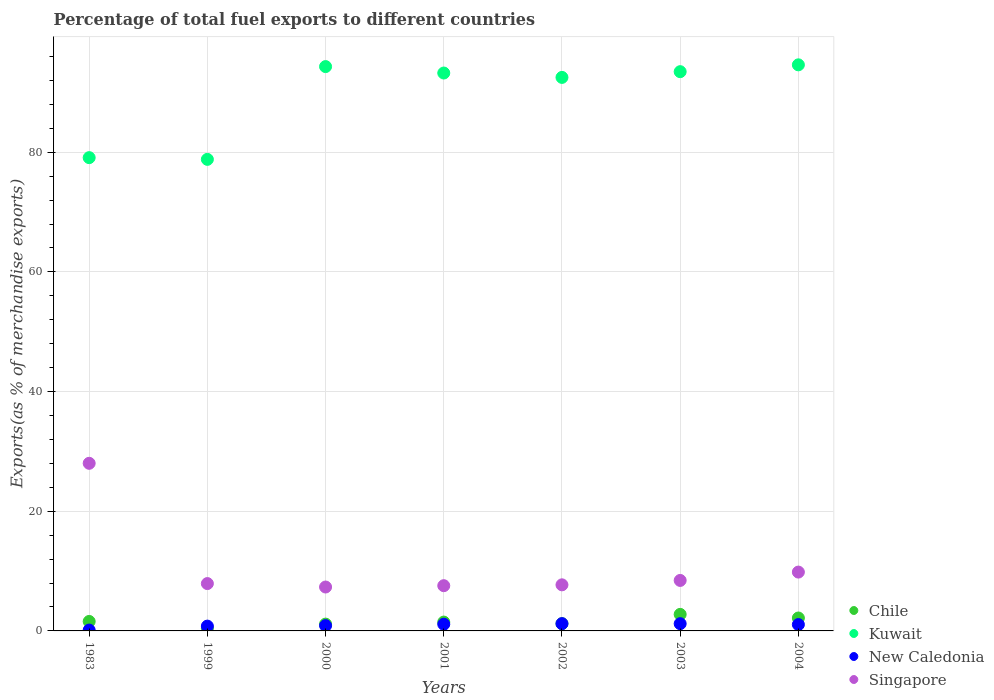How many different coloured dotlines are there?
Give a very brief answer. 4. Is the number of dotlines equal to the number of legend labels?
Offer a terse response. Yes. What is the percentage of exports to different countries in Chile in 2002?
Your answer should be very brief. 1.21. Across all years, what is the maximum percentage of exports to different countries in New Caledonia?
Keep it short and to the point. 1.22. Across all years, what is the minimum percentage of exports to different countries in Singapore?
Keep it short and to the point. 7.34. In which year was the percentage of exports to different countries in Kuwait maximum?
Keep it short and to the point. 2004. In which year was the percentage of exports to different countries in Chile minimum?
Provide a succinct answer. 1999. What is the total percentage of exports to different countries in Singapore in the graph?
Give a very brief answer. 76.79. What is the difference between the percentage of exports to different countries in New Caledonia in 1999 and that in 2000?
Keep it short and to the point. -0.08. What is the difference between the percentage of exports to different countries in New Caledonia in 1983 and the percentage of exports to different countries in Kuwait in 2001?
Give a very brief answer. -93.09. What is the average percentage of exports to different countries in Singapore per year?
Give a very brief answer. 10.97. In the year 2001, what is the difference between the percentage of exports to different countries in New Caledonia and percentage of exports to different countries in Kuwait?
Your answer should be compact. -92.11. What is the ratio of the percentage of exports to different countries in Kuwait in 2001 to that in 2003?
Your answer should be compact. 1. Is the percentage of exports to different countries in Chile in 1999 less than that in 2000?
Give a very brief answer. Yes. What is the difference between the highest and the second highest percentage of exports to different countries in New Caledonia?
Give a very brief answer. 0.01. What is the difference between the highest and the lowest percentage of exports to different countries in Chile?
Your response must be concise. 2.32. In how many years, is the percentage of exports to different countries in Chile greater than the average percentage of exports to different countries in Chile taken over all years?
Offer a terse response. 3. Is the sum of the percentage of exports to different countries in Kuwait in 2000 and 2003 greater than the maximum percentage of exports to different countries in Chile across all years?
Your answer should be very brief. Yes. Is it the case that in every year, the sum of the percentage of exports to different countries in Chile and percentage of exports to different countries in New Caledonia  is greater than the percentage of exports to different countries in Singapore?
Provide a succinct answer. No. Does the percentage of exports to different countries in Chile monotonically increase over the years?
Ensure brevity in your answer.  No. Is the percentage of exports to different countries in Chile strictly greater than the percentage of exports to different countries in Singapore over the years?
Offer a very short reply. No. How many dotlines are there?
Give a very brief answer. 4. How many years are there in the graph?
Provide a succinct answer. 7. Are the values on the major ticks of Y-axis written in scientific E-notation?
Offer a terse response. No. Does the graph contain any zero values?
Make the answer very short. No. Where does the legend appear in the graph?
Give a very brief answer. Bottom right. How many legend labels are there?
Give a very brief answer. 4. How are the legend labels stacked?
Provide a short and direct response. Vertical. What is the title of the graph?
Ensure brevity in your answer.  Percentage of total fuel exports to different countries. What is the label or title of the X-axis?
Provide a short and direct response. Years. What is the label or title of the Y-axis?
Offer a very short reply. Exports(as % of merchandise exports). What is the Exports(as % of merchandise exports) of Chile in 1983?
Offer a very short reply. 1.58. What is the Exports(as % of merchandise exports) in Kuwait in 1983?
Your answer should be compact. 79.09. What is the Exports(as % of merchandise exports) of New Caledonia in 1983?
Ensure brevity in your answer.  0.14. What is the Exports(as % of merchandise exports) of Singapore in 1983?
Your answer should be compact. 28.01. What is the Exports(as % of merchandise exports) in Chile in 1999?
Make the answer very short. 0.44. What is the Exports(as % of merchandise exports) of Kuwait in 1999?
Your answer should be compact. 78.8. What is the Exports(as % of merchandise exports) in New Caledonia in 1999?
Make the answer very short. 0.8. What is the Exports(as % of merchandise exports) of Singapore in 1999?
Make the answer very short. 7.91. What is the Exports(as % of merchandise exports) of Chile in 2000?
Your response must be concise. 1.14. What is the Exports(as % of merchandise exports) of Kuwait in 2000?
Offer a terse response. 94.31. What is the Exports(as % of merchandise exports) in New Caledonia in 2000?
Your answer should be compact. 0.88. What is the Exports(as % of merchandise exports) of Singapore in 2000?
Keep it short and to the point. 7.34. What is the Exports(as % of merchandise exports) of Chile in 2001?
Offer a very short reply. 1.48. What is the Exports(as % of merchandise exports) of Kuwait in 2001?
Your answer should be compact. 93.23. What is the Exports(as % of merchandise exports) of New Caledonia in 2001?
Provide a succinct answer. 1.12. What is the Exports(as % of merchandise exports) in Singapore in 2001?
Your answer should be compact. 7.56. What is the Exports(as % of merchandise exports) of Chile in 2002?
Make the answer very short. 1.21. What is the Exports(as % of merchandise exports) in Kuwait in 2002?
Ensure brevity in your answer.  92.5. What is the Exports(as % of merchandise exports) in New Caledonia in 2002?
Offer a very short reply. 1.22. What is the Exports(as % of merchandise exports) in Singapore in 2002?
Provide a succinct answer. 7.7. What is the Exports(as % of merchandise exports) in Chile in 2003?
Make the answer very short. 2.76. What is the Exports(as % of merchandise exports) in Kuwait in 2003?
Your answer should be compact. 93.46. What is the Exports(as % of merchandise exports) of New Caledonia in 2003?
Offer a terse response. 1.21. What is the Exports(as % of merchandise exports) in Singapore in 2003?
Make the answer very short. 8.44. What is the Exports(as % of merchandise exports) of Chile in 2004?
Your answer should be compact. 2.16. What is the Exports(as % of merchandise exports) in Kuwait in 2004?
Your answer should be compact. 94.6. What is the Exports(as % of merchandise exports) of New Caledonia in 2004?
Offer a terse response. 1.06. What is the Exports(as % of merchandise exports) in Singapore in 2004?
Offer a very short reply. 9.83. Across all years, what is the maximum Exports(as % of merchandise exports) in Chile?
Keep it short and to the point. 2.76. Across all years, what is the maximum Exports(as % of merchandise exports) of Kuwait?
Ensure brevity in your answer.  94.6. Across all years, what is the maximum Exports(as % of merchandise exports) in New Caledonia?
Your answer should be very brief. 1.22. Across all years, what is the maximum Exports(as % of merchandise exports) in Singapore?
Give a very brief answer. 28.01. Across all years, what is the minimum Exports(as % of merchandise exports) of Chile?
Your answer should be very brief. 0.44. Across all years, what is the minimum Exports(as % of merchandise exports) in Kuwait?
Your answer should be compact. 78.8. Across all years, what is the minimum Exports(as % of merchandise exports) of New Caledonia?
Your answer should be compact. 0.14. Across all years, what is the minimum Exports(as % of merchandise exports) of Singapore?
Offer a terse response. 7.34. What is the total Exports(as % of merchandise exports) of Chile in the graph?
Give a very brief answer. 10.77. What is the total Exports(as % of merchandise exports) in Kuwait in the graph?
Give a very brief answer. 625.98. What is the total Exports(as % of merchandise exports) of New Caledonia in the graph?
Keep it short and to the point. 6.43. What is the total Exports(as % of merchandise exports) of Singapore in the graph?
Ensure brevity in your answer.  76.79. What is the difference between the Exports(as % of merchandise exports) in Chile in 1983 and that in 1999?
Your answer should be very brief. 1.14. What is the difference between the Exports(as % of merchandise exports) in Kuwait in 1983 and that in 1999?
Offer a very short reply. 0.29. What is the difference between the Exports(as % of merchandise exports) of New Caledonia in 1983 and that in 1999?
Make the answer very short. -0.66. What is the difference between the Exports(as % of merchandise exports) in Singapore in 1983 and that in 1999?
Your answer should be compact. 20.1. What is the difference between the Exports(as % of merchandise exports) in Chile in 1983 and that in 2000?
Make the answer very short. 0.45. What is the difference between the Exports(as % of merchandise exports) in Kuwait in 1983 and that in 2000?
Keep it short and to the point. -15.22. What is the difference between the Exports(as % of merchandise exports) in New Caledonia in 1983 and that in 2000?
Your answer should be compact. -0.74. What is the difference between the Exports(as % of merchandise exports) of Singapore in 1983 and that in 2000?
Your response must be concise. 20.67. What is the difference between the Exports(as % of merchandise exports) in Chile in 1983 and that in 2001?
Your answer should be very brief. 0.11. What is the difference between the Exports(as % of merchandise exports) of Kuwait in 1983 and that in 2001?
Give a very brief answer. -14.14. What is the difference between the Exports(as % of merchandise exports) of New Caledonia in 1983 and that in 2001?
Provide a short and direct response. -0.98. What is the difference between the Exports(as % of merchandise exports) in Singapore in 1983 and that in 2001?
Offer a very short reply. 20.45. What is the difference between the Exports(as % of merchandise exports) in Chile in 1983 and that in 2002?
Provide a succinct answer. 0.37. What is the difference between the Exports(as % of merchandise exports) of Kuwait in 1983 and that in 2002?
Give a very brief answer. -13.41. What is the difference between the Exports(as % of merchandise exports) of New Caledonia in 1983 and that in 2002?
Provide a short and direct response. -1.07. What is the difference between the Exports(as % of merchandise exports) in Singapore in 1983 and that in 2002?
Your answer should be compact. 20.31. What is the difference between the Exports(as % of merchandise exports) of Chile in 1983 and that in 2003?
Your answer should be very brief. -1.18. What is the difference between the Exports(as % of merchandise exports) in Kuwait in 1983 and that in 2003?
Provide a succinct answer. -14.37. What is the difference between the Exports(as % of merchandise exports) of New Caledonia in 1983 and that in 2003?
Provide a succinct answer. -1.07. What is the difference between the Exports(as % of merchandise exports) of Singapore in 1983 and that in 2003?
Offer a very short reply. 19.57. What is the difference between the Exports(as % of merchandise exports) of Chile in 1983 and that in 2004?
Your answer should be very brief. -0.58. What is the difference between the Exports(as % of merchandise exports) of Kuwait in 1983 and that in 2004?
Make the answer very short. -15.51. What is the difference between the Exports(as % of merchandise exports) of New Caledonia in 1983 and that in 2004?
Give a very brief answer. -0.92. What is the difference between the Exports(as % of merchandise exports) of Singapore in 1983 and that in 2004?
Give a very brief answer. 18.18. What is the difference between the Exports(as % of merchandise exports) of Chile in 1999 and that in 2000?
Give a very brief answer. -0.69. What is the difference between the Exports(as % of merchandise exports) in Kuwait in 1999 and that in 2000?
Provide a short and direct response. -15.5. What is the difference between the Exports(as % of merchandise exports) in New Caledonia in 1999 and that in 2000?
Offer a very short reply. -0.08. What is the difference between the Exports(as % of merchandise exports) of Singapore in 1999 and that in 2000?
Offer a terse response. 0.57. What is the difference between the Exports(as % of merchandise exports) in Chile in 1999 and that in 2001?
Your answer should be compact. -1.03. What is the difference between the Exports(as % of merchandise exports) of Kuwait in 1999 and that in 2001?
Give a very brief answer. -14.43. What is the difference between the Exports(as % of merchandise exports) of New Caledonia in 1999 and that in 2001?
Provide a succinct answer. -0.32. What is the difference between the Exports(as % of merchandise exports) in Singapore in 1999 and that in 2001?
Provide a short and direct response. 0.35. What is the difference between the Exports(as % of merchandise exports) of Chile in 1999 and that in 2002?
Your answer should be very brief. -0.77. What is the difference between the Exports(as % of merchandise exports) of Kuwait in 1999 and that in 2002?
Your answer should be compact. -13.7. What is the difference between the Exports(as % of merchandise exports) of New Caledonia in 1999 and that in 2002?
Offer a very short reply. -0.41. What is the difference between the Exports(as % of merchandise exports) in Singapore in 1999 and that in 2002?
Provide a short and direct response. 0.21. What is the difference between the Exports(as % of merchandise exports) of Chile in 1999 and that in 2003?
Give a very brief answer. -2.32. What is the difference between the Exports(as % of merchandise exports) of Kuwait in 1999 and that in 2003?
Your answer should be very brief. -14.65. What is the difference between the Exports(as % of merchandise exports) in New Caledonia in 1999 and that in 2003?
Provide a short and direct response. -0.41. What is the difference between the Exports(as % of merchandise exports) in Singapore in 1999 and that in 2003?
Offer a terse response. -0.53. What is the difference between the Exports(as % of merchandise exports) of Chile in 1999 and that in 2004?
Your answer should be very brief. -1.72. What is the difference between the Exports(as % of merchandise exports) of Kuwait in 1999 and that in 2004?
Offer a very short reply. -15.8. What is the difference between the Exports(as % of merchandise exports) in New Caledonia in 1999 and that in 2004?
Ensure brevity in your answer.  -0.26. What is the difference between the Exports(as % of merchandise exports) of Singapore in 1999 and that in 2004?
Offer a very short reply. -1.92. What is the difference between the Exports(as % of merchandise exports) in Chile in 2000 and that in 2001?
Provide a short and direct response. -0.34. What is the difference between the Exports(as % of merchandise exports) of Kuwait in 2000 and that in 2001?
Ensure brevity in your answer.  1.08. What is the difference between the Exports(as % of merchandise exports) in New Caledonia in 2000 and that in 2001?
Make the answer very short. -0.24. What is the difference between the Exports(as % of merchandise exports) of Singapore in 2000 and that in 2001?
Your answer should be compact. -0.22. What is the difference between the Exports(as % of merchandise exports) in Chile in 2000 and that in 2002?
Make the answer very short. -0.07. What is the difference between the Exports(as % of merchandise exports) of Kuwait in 2000 and that in 2002?
Your response must be concise. 1.81. What is the difference between the Exports(as % of merchandise exports) of New Caledonia in 2000 and that in 2002?
Offer a very short reply. -0.33. What is the difference between the Exports(as % of merchandise exports) of Singapore in 2000 and that in 2002?
Provide a short and direct response. -0.37. What is the difference between the Exports(as % of merchandise exports) in Chile in 2000 and that in 2003?
Your answer should be very brief. -1.63. What is the difference between the Exports(as % of merchandise exports) in Kuwait in 2000 and that in 2003?
Keep it short and to the point. 0.85. What is the difference between the Exports(as % of merchandise exports) in New Caledonia in 2000 and that in 2003?
Make the answer very short. -0.33. What is the difference between the Exports(as % of merchandise exports) of Singapore in 2000 and that in 2003?
Provide a short and direct response. -1.1. What is the difference between the Exports(as % of merchandise exports) of Chile in 2000 and that in 2004?
Provide a short and direct response. -1.02. What is the difference between the Exports(as % of merchandise exports) in Kuwait in 2000 and that in 2004?
Make the answer very short. -0.29. What is the difference between the Exports(as % of merchandise exports) in New Caledonia in 2000 and that in 2004?
Give a very brief answer. -0.18. What is the difference between the Exports(as % of merchandise exports) in Singapore in 2000 and that in 2004?
Your answer should be compact. -2.5. What is the difference between the Exports(as % of merchandise exports) of Chile in 2001 and that in 2002?
Your answer should be compact. 0.27. What is the difference between the Exports(as % of merchandise exports) in Kuwait in 2001 and that in 2002?
Provide a short and direct response. 0.73. What is the difference between the Exports(as % of merchandise exports) in New Caledonia in 2001 and that in 2002?
Offer a terse response. -0.1. What is the difference between the Exports(as % of merchandise exports) of Singapore in 2001 and that in 2002?
Your response must be concise. -0.14. What is the difference between the Exports(as % of merchandise exports) in Chile in 2001 and that in 2003?
Provide a short and direct response. -1.29. What is the difference between the Exports(as % of merchandise exports) of Kuwait in 2001 and that in 2003?
Offer a very short reply. -0.23. What is the difference between the Exports(as % of merchandise exports) of New Caledonia in 2001 and that in 2003?
Provide a short and direct response. -0.09. What is the difference between the Exports(as % of merchandise exports) in Singapore in 2001 and that in 2003?
Give a very brief answer. -0.88. What is the difference between the Exports(as % of merchandise exports) of Chile in 2001 and that in 2004?
Offer a very short reply. -0.68. What is the difference between the Exports(as % of merchandise exports) in Kuwait in 2001 and that in 2004?
Give a very brief answer. -1.37. What is the difference between the Exports(as % of merchandise exports) in New Caledonia in 2001 and that in 2004?
Ensure brevity in your answer.  0.06. What is the difference between the Exports(as % of merchandise exports) in Singapore in 2001 and that in 2004?
Your answer should be compact. -2.27. What is the difference between the Exports(as % of merchandise exports) in Chile in 2002 and that in 2003?
Ensure brevity in your answer.  -1.55. What is the difference between the Exports(as % of merchandise exports) in Kuwait in 2002 and that in 2003?
Your response must be concise. -0.96. What is the difference between the Exports(as % of merchandise exports) in New Caledonia in 2002 and that in 2003?
Your answer should be very brief. 0.01. What is the difference between the Exports(as % of merchandise exports) of Singapore in 2002 and that in 2003?
Give a very brief answer. -0.73. What is the difference between the Exports(as % of merchandise exports) of Chile in 2002 and that in 2004?
Provide a succinct answer. -0.95. What is the difference between the Exports(as % of merchandise exports) in New Caledonia in 2002 and that in 2004?
Make the answer very short. 0.15. What is the difference between the Exports(as % of merchandise exports) of Singapore in 2002 and that in 2004?
Your answer should be compact. -2.13. What is the difference between the Exports(as % of merchandise exports) of Chile in 2003 and that in 2004?
Make the answer very short. 0.6. What is the difference between the Exports(as % of merchandise exports) in Kuwait in 2003 and that in 2004?
Offer a very short reply. -1.14. What is the difference between the Exports(as % of merchandise exports) in New Caledonia in 2003 and that in 2004?
Provide a succinct answer. 0.15. What is the difference between the Exports(as % of merchandise exports) in Singapore in 2003 and that in 2004?
Make the answer very short. -1.4. What is the difference between the Exports(as % of merchandise exports) in Chile in 1983 and the Exports(as % of merchandise exports) in Kuwait in 1999?
Your answer should be compact. -77.22. What is the difference between the Exports(as % of merchandise exports) of Chile in 1983 and the Exports(as % of merchandise exports) of New Caledonia in 1999?
Give a very brief answer. 0.78. What is the difference between the Exports(as % of merchandise exports) in Chile in 1983 and the Exports(as % of merchandise exports) in Singapore in 1999?
Make the answer very short. -6.33. What is the difference between the Exports(as % of merchandise exports) in Kuwait in 1983 and the Exports(as % of merchandise exports) in New Caledonia in 1999?
Offer a terse response. 78.29. What is the difference between the Exports(as % of merchandise exports) of Kuwait in 1983 and the Exports(as % of merchandise exports) of Singapore in 1999?
Your response must be concise. 71.18. What is the difference between the Exports(as % of merchandise exports) in New Caledonia in 1983 and the Exports(as % of merchandise exports) in Singapore in 1999?
Your answer should be very brief. -7.77. What is the difference between the Exports(as % of merchandise exports) of Chile in 1983 and the Exports(as % of merchandise exports) of Kuwait in 2000?
Offer a very short reply. -92.72. What is the difference between the Exports(as % of merchandise exports) in Chile in 1983 and the Exports(as % of merchandise exports) in New Caledonia in 2000?
Keep it short and to the point. 0.7. What is the difference between the Exports(as % of merchandise exports) of Chile in 1983 and the Exports(as % of merchandise exports) of Singapore in 2000?
Keep it short and to the point. -5.75. What is the difference between the Exports(as % of merchandise exports) of Kuwait in 1983 and the Exports(as % of merchandise exports) of New Caledonia in 2000?
Your answer should be very brief. 78.21. What is the difference between the Exports(as % of merchandise exports) in Kuwait in 1983 and the Exports(as % of merchandise exports) in Singapore in 2000?
Give a very brief answer. 71.75. What is the difference between the Exports(as % of merchandise exports) in New Caledonia in 1983 and the Exports(as % of merchandise exports) in Singapore in 2000?
Offer a very short reply. -7.2. What is the difference between the Exports(as % of merchandise exports) in Chile in 1983 and the Exports(as % of merchandise exports) in Kuwait in 2001?
Offer a very short reply. -91.65. What is the difference between the Exports(as % of merchandise exports) in Chile in 1983 and the Exports(as % of merchandise exports) in New Caledonia in 2001?
Offer a very short reply. 0.46. What is the difference between the Exports(as % of merchandise exports) of Chile in 1983 and the Exports(as % of merchandise exports) of Singapore in 2001?
Make the answer very short. -5.98. What is the difference between the Exports(as % of merchandise exports) in Kuwait in 1983 and the Exports(as % of merchandise exports) in New Caledonia in 2001?
Provide a succinct answer. 77.97. What is the difference between the Exports(as % of merchandise exports) of Kuwait in 1983 and the Exports(as % of merchandise exports) of Singapore in 2001?
Make the answer very short. 71.53. What is the difference between the Exports(as % of merchandise exports) in New Caledonia in 1983 and the Exports(as % of merchandise exports) in Singapore in 2001?
Your answer should be compact. -7.42. What is the difference between the Exports(as % of merchandise exports) in Chile in 1983 and the Exports(as % of merchandise exports) in Kuwait in 2002?
Provide a short and direct response. -90.92. What is the difference between the Exports(as % of merchandise exports) in Chile in 1983 and the Exports(as % of merchandise exports) in New Caledonia in 2002?
Your answer should be compact. 0.37. What is the difference between the Exports(as % of merchandise exports) in Chile in 1983 and the Exports(as % of merchandise exports) in Singapore in 2002?
Provide a succinct answer. -6.12. What is the difference between the Exports(as % of merchandise exports) in Kuwait in 1983 and the Exports(as % of merchandise exports) in New Caledonia in 2002?
Your answer should be very brief. 77.87. What is the difference between the Exports(as % of merchandise exports) in Kuwait in 1983 and the Exports(as % of merchandise exports) in Singapore in 2002?
Make the answer very short. 71.39. What is the difference between the Exports(as % of merchandise exports) of New Caledonia in 1983 and the Exports(as % of merchandise exports) of Singapore in 2002?
Offer a terse response. -7.56. What is the difference between the Exports(as % of merchandise exports) of Chile in 1983 and the Exports(as % of merchandise exports) of Kuwait in 2003?
Your response must be concise. -91.87. What is the difference between the Exports(as % of merchandise exports) of Chile in 1983 and the Exports(as % of merchandise exports) of New Caledonia in 2003?
Your answer should be compact. 0.37. What is the difference between the Exports(as % of merchandise exports) of Chile in 1983 and the Exports(as % of merchandise exports) of Singapore in 2003?
Your answer should be very brief. -6.85. What is the difference between the Exports(as % of merchandise exports) of Kuwait in 1983 and the Exports(as % of merchandise exports) of New Caledonia in 2003?
Give a very brief answer. 77.88. What is the difference between the Exports(as % of merchandise exports) in Kuwait in 1983 and the Exports(as % of merchandise exports) in Singapore in 2003?
Give a very brief answer. 70.65. What is the difference between the Exports(as % of merchandise exports) in New Caledonia in 1983 and the Exports(as % of merchandise exports) in Singapore in 2003?
Provide a succinct answer. -8.3. What is the difference between the Exports(as % of merchandise exports) in Chile in 1983 and the Exports(as % of merchandise exports) in Kuwait in 2004?
Make the answer very short. -93.02. What is the difference between the Exports(as % of merchandise exports) of Chile in 1983 and the Exports(as % of merchandise exports) of New Caledonia in 2004?
Offer a terse response. 0.52. What is the difference between the Exports(as % of merchandise exports) of Chile in 1983 and the Exports(as % of merchandise exports) of Singapore in 2004?
Your response must be concise. -8.25. What is the difference between the Exports(as % of merchandise exports) of Kuwait in 1983 and the Exports(as % of merchandise exports) of New Caledonia in 2004?
Your response must be concise. 78.03. What is the difference between the Exports(as % of merchandise exports) in Kuwait in 1983 and the Exports(as % of merchandise exports) in Singapore in 2004?
Keep it short and to the point. 69.26. What is the difference between the Exports(as % of merchandise exports) in New Caledonia in 1983 and the Exports(as % of merchandise exports) in Singapore in 2004?
Give a very brief answer. -9.69. What is the difference between the Exports(as % of merchandise exports) in Chile in 1999 and the Exports(as % of merchandise exports) in Kuwait in 2000?
Provide a succinct answer. -93.86. What is the difference between the Exports(as % of merchandise exports) of Chile in 1999 and the Exports(as % of merchandise exports) of New Caledonia in 2000?
Offer a terse response. -0.44. What is the difference between the Exports(as % of merchandise exports) in Chile in 1999 and the Exports(as % of merchandise exports) in Singapore in 2000?
Your answer should be compact. -6.89. What is the difference between the Exports(as % of merchandise exports) in Kuwait in 1999 and the Exports(as % of merchandise exports) in New Caledonia in 2000?
Offer a very short reply. 77.92. What is the difference between the Exports(as % of merchandise exports) in Kuwait in 1999 and the Exports(as % of merchandise exports) in Singapore in 2000?
Make the answer very short. 71.47. What is the difference between the Exports(as % of merchandise exports) in New Caledonia in 1999 and the Exports(as % of merchandise exports) in Singapore in 2000?
Provide a succinct answer. -6.53. What is the difference between the Exports(as % of merchandise exports) of Chile in 1999 and the Exports(as % of merchandise exports) of Kuwait in 2001?
Provide a short and direct response. -92.79. What is the difference between the Exports(as % of merchandise exports) of Chile in 1999 and the Exports(as % of merchandise exports) of New Caledonia in 2001?
Keep it short and to the point. -0.68. What is the difference between the Exports(as % of merchandise exports) in Chile in 1999 and the Exports(as % of merchandise exports) in Singapore in 2001?
Give a very brief answer. -7.12. What is the difference between the Exports(as % of merchandise exports) in Kuwait in 1999 and the Exports(as % of merchandise exports) in New Caledonia in 2001?
Provide a succinct answer. 77.68. What is the difference between the Exports(as % of merchandise exports) in Kuwait in 1999 and the Exports(as % of merchandise exports) in Singapore in 2001?
Make the answer very short. 71.24. What is the difference between the Exports(as % of merchandise exports) in New Caledonia in 1999 and the Exports(as % of merchandise exports) in Singapore in 2001?
Your response must be concise. -6.76. What is the difference between the Exports(as % of merchandise exports) of Chile in 1999 and the Exports(as % of merchandise exports) of Kuwait in 2002?
Your answer should be very brief. -92.06. What is the difference between the Exports(as % of merchandise exports) in Chile in 1999 and the Exports(as % of merchandise exports) in New Caledonia in 2002?
Keep it short and to the point. -0.77. What is the difference between the Exports(as % of merchandise exports) in Chile in 1999 and the Exports(as % of merchandise exports) in Singapore in 2002?
Provide a succinct answer. -7.26. What is the difference between the Exports(as % of merchandise exports) of Kuwait in 1999 and the Exports(as % of merchandise exports) of New Caledonia in 2002?
Keep it short and to the point. 77.59. What is the difference between the Exports(as % of merchandise exports) of Kuwait in 1999 and the Exports(as % of merchandise exports) of Singapore in 2002?
Your answer should be very brief. 71.1. What is the difference between the Exports(as % of merchandise exports) in New Caledonia in 1999 and the Exports(as % of merchandise exports) in Singapore in 2002?
Your answer should be very brief. -6.9. What is the difference between the Exports(as % of merchandise exports) of Chile in 1999 and the Exports(as % of merchandise exports) of Kuwait in 2003?
Keep it short and to the point. -93.01. What is the difference between the Exports(as % of merchandise exports) in Chile in 1999 and the Exports(as % of merchandise exports) in New Caledonia in 2003?
Provide a succinct answer. -0.77. What is the difference between the Exports(as % of merchandise exports) in Chile in 1999 and the Exports(as % of merchandise exports) in Singapore in 2003?
Give a very brief answer. -7.99. What is the difference between the Exports(as % of merchandise exports) of Kuwait in 1999 and the Exports(as % of merchandise exports) of New Caledonia in 2003?
Your answer should be compact. 77.59. What is the difference between the Exports(as % of merchandise exports) of Kuwait in 1999 and the Exports(as % of merchandise exports) of Singapore in 2003?
Offer a very short reply. 70.37. What is the difference between the Exports(as % of merchandise exports) in New Caledonia in 1999 and the Exports(as % of merchandise exports) in Singapore in 2003?
Your answer should be compact. -7.63. What is the difference between the Exports(as % of merchandise exports) in Chile in 1999 and the Exports(as % of merchandise exports) in Kuwait in 2004?
Your response must be concise. -94.16. What is the difference between the Exports(as % of merchandise exports) of Chile in 1999 and the Exports(as % of merchandise exports) of New Caledonia in 2004?
Offer a terse response. -0.62. What is the difference between the Exports(as % of merchandise exports) of Chile in 1999 and the Exports(as % of merchandise exports) of Singapore in 2004?
Make the answer very short. -9.39. What is the difference between the Exports(as % of merchandise exports) of Kuwait in 1999 and the Exports(as % of merchandise exports) of New Caledonia in 2004?
Provide a succinct answer. 77.74. What is the difference between the Exports(as % of merchandise exports) of Kuwait in 1999 and the Exports(as % of merchandise exports) of Singapore in 2004?
Offer a very short reply. 68.97. What is the difference between the Exports(as % of merchandise exports) in New Caledonia in 1999 and the Exports(as % of merchandise exports) in Singapore in 2004?
Give a very brief answer. -9.03. What is the difference between the Exports(as % of merchandise exports) of Chile in 2000 and the Exports(as % of merchandise exports) of Kuwait in 2001?
Your response must be concise. -92.09. What is the difference between the Exports(as % of merchandise exports) of Chile in 2000 and the Exports(as % of merchandise exports) of New Caledonia in 2001?
Provide a succinct answer. 0.02. What is the difference between the Exports(as % of merchandise exports) of Chile in 2000 and the Exports(as % of merchandise exports) of Singapore in 2001?
Make the answer very short. -6.42. What is the difference between the Exports(as % of merchandise exports) of Kuwait in 2000 and the Exports(as % of merchandise exports) of New Caledonia in 2001?
Your response must be concise. 93.19. What is the difference between the Exports(as % of merchandise exports) of Kuwait in 2000 and the Exports(as % of merchandise exports) of Singapore in 2001?
Offer a very short reply. 86.75. What is the difference between the Exports(as % of merchandise exports) in New Caledonia in 2000 and the Exports(as % of merchandise exports) in Singapore in 2001?
Make the answer very short. -6.68. What is the difference between the Exports(as % of merchandise exports) in Chile in 2000 and the Exports(as % of merchandise exports) in Kuwait in 2002?
Give a very brief answer. -91.36. What is the difference between the Exports(as % of merchandise exports) in Chile in 2000 and the Exports(as % of merchandise exports) in New Caledonia in 2002?
Make the answer very short. -0.08. What is the difference between the Exports(as % of merchandise exports) of Chile in 2000 and the Exports(as % of merchandise exports) of Singapore in 2002?
Ensure brevity in your answer.  -6.56. What is the difference between the Exports(as % of merchandise exports) in Kuwait in 2000 and the Exports(as % of merchandise exports) in New Caledonia in 2002?
Offer a terse response. 93.09. What is the difference between the Exports(as % of merchandise exports) of Kuwait in 2000 and the Exports(as % of merchandise exports) of Singapore in 2002?
Provide a succinct answer. 86.6. What is the difference between the Exports(as % of merchandise exports) in New Caledonia in 2000 and the Exports(as % of merchandise exports) in Singapore in 2002?
Your answer should be very brief. -6.82. What is the difference between the Exports(as % of merchandise exports) of Chile in 2000 and the Exports(as % of merchandise exports) of Kuwait in 2003?
Ensure brevity in your answer.  -92.32. What is the difference between the Exports(as % of merchandise exports) in Chile in 2000 and the Exports(as % of merchandise exports) in New Caledonia in 2003?
Keep it short and to the point. -0.07. What is the difference between the Exports(as % of merchandise exports) in Chile in 2000 and the Exports(as % of merchandise exports) in Singapore in 2003?
Give a very brief answer. -7.3. What is the difference between the Exports(as % of merchandise exports) in Kuwait in 2000 and the Exports(as % of merchandise exports) in New Caledonia in 2003?
Offer a terse response. 93.1. What is the difference between the Exports(as % of merchandise exports) in Kuwait in 2000 and the Exports(as % of merchandise exports) in Singapore in 2003?
Provide a short and direct response. 85.87. What is the difference between the Exports(as % of merchandise exports) in New Caledonia in 2000 and the Exports(as % of merchandise exports) in Singapore in 2003?
Offer a very short reply. -7.55. What is the difference between the Exports(as % of merchandise exports) in Chile in 2000 and the Exports(as % of merchandise exports) in Kuwait in 2004?
Your answer should be very brief. -93.46. What is the difference between the Exports(as % of merchandise exports) in Chile in 2000 and the Exports(as % of merchandise exports) in New Caledonia in 2004?
Offer a very short reply. 0.07. What is the difference between the Exports(as % of merchandise exports) in Chile in 2000 and the Exports(as % of merchandise exports) in Singapore in 2004?
Your answer should be compact. -8.69. What is the difference between the Exports(as % of merchandise exports) of Kuwait in 2000 and the Exports(as % of merchandise exports) of New Caledonia in 2004?
Make the answer very short. 93.24. What is the difference between the Exports(as % of merchandise exports) of Kuwait in 2000 and the Exports(as % of merchandise exports) of Singapore in 2004?
Provide a short and direct response. 84.47. What is the difference between the Exports(as % of merchandise exports) in New Caledonia in 2000 and the Exports(as % of merchandise exports) in Singapore in 2004?
Provide a short and direct response. -8.95. What is the difference between the Exports(as % of merchandise exports) in Chile in 2001 and the Exports(as % of merchandise exports) in Kuwait in 2002?
Provide a succinct answer. -91.02. What is the difference between the Exports(as % of merchandise exports) in Chile in 2001 and the Exports(as % of merchandise exports) in New Caledonia in 2002?
Make the answer very short. 0.26. What is the difference between the Exports(as % of merchandise exports) in Chile in 2001 and the Exports(as % of merchandise exports) in Singapore in 2002?
Your answer should be very brief. -6.23. What is the difference between the Exports(as % of merchandise exports) of Kuwait in 2001 and the Exports(as % of merchandise exports) of New Caledonia in 2002?
Your answer should be very brief. 92.02. What is the difference between the Exports(as % of merchandise exports) in Kuwait in 2001 and the Exports(as % of merchandise exports) in Singapore in 2002?
Provide a succinct answer. 85.53. What is the difference between the Exports(as % of merchandise exports) of New Caledonia in 2001 and the Exports(as % of merchandise exports) of Singapore in 2002?
Provide a short and direct response. -6.58. What is the difference between the Exports(as % of merchandise exports) of Chile in 2001 and the Exports(as % of merchandise exports) of Kuwait in 2003?
Ensure brevity in your answer.  -91.98. What is the difference between the Exports(as % of merchandise exports) of Chile in 2001 and the Exports(as % of merchandise exports) of New Caledonia in 2003?
Give a very brief answer. 0.27. What is the difference between the Exports(as % of merchandise exports) of Chile in 2001 and the Exports(as % of merchandise exports) of Singapore in 2003?
Make the answer very short. -6.96. What is the difference between the Exports(as % of merchandise exports) of Kuwait in 2001 and the Exports(as % of merchandise exports) of New Caledonia in 2003?
Give a very brief answer. 92.02. What is the difference between the Exports(as % of merchandise exports) in Kuwait in 2001 and the Exports(as % of merchandise exports) in Singapore in 2003?
Offer a very short reply. 84.79. What is the difference between the Exports(as % of merchandise exports) in New Caledonia in 2001 and the Exports(as % of merchandise exports) in Singapore in 2003?
Offer a very short reply. -7.32. What is the difference between the Exports(as % of merchandise exports) of Chile in 2001 and the Exports(as % of merchandise exports) of Kuwait in 2004?
Offer a very short reply. -93.12. What is the difference between the Exports(as % of merchandise exports) in Chile in 2001 and the Exports(as % of merchandise exports) in New Caledonia in 2004?
Your answer should be very brief. 0.41. What is the difference between the Exports(as % of merchandise exports) of Chile in 2001 and the Exports(as % of merchandise exports) of Singapore in 2004?
Provide a succinct answer. -8.36. What is the difference between the Exports(as % of merchandise exports) in Kuwait in 2001 and the Exports(as % of merchandise exports) in New Caledonia in 2004?
Offer a terse response. 92.17. What is the difference between the Exports(as % of merchandise exports) of Kuwait in 2001 and the Exports(as % of merchandise exports) of Singapore in 2004?
Provide a short and direct response. 83.4. What is the difference between the Exports(as % of merchandise exports) of New Caledonia in 2001 and the Exports(as % of merchandise exports) of Singapore in 2004?
Your response must be concise. -8.71. What is the difference between the Exports(as % of merchandise exports) in Chile in 2002 and the Exports(as % of merchandise exports) in Kuwait in 2003?
Keep it short and to the point. -92.25. What is the difference between the Exports(as % of merchandise exports) in Chile in 2002 and the Exports(as % of merchandise exports) in Singapore in 2003?
Provide a succinct answer. -7.23. What is the difference between the Exports(as % of merchandise exports) of Kuwait in 2002 and the Exports(as % of merchandise exports) of New Caledonia in 2003?
Your response must be concise. 91.29. What is the difference between the Exports(as % of merchandise exports) in Kuwait in 2002 and the Exports(as % of merchandise exports) in Singapore in 2003?
Provide a short and direct response. 84.06. What is the difference between the Exports(as % of merchandise exports) of New Caledonia in 2002 and the Exports(as % of merchandise exports) of Singapore in 2003?
Offer a very short reply. -7.22. What is the difference between the Exports(as % of merchandise exports) in Chile in 2002 and the Exports(as % of merchandise exports) in Kuwait in 2004?
Offer a very short reply. -93.39. What is the difference between the Exports(as % of merchandise exports) of Chile in 2002 and the Exports(as % of merchandise exports) of New Caledonia in 2004?
Offer a very short reply. 0.15. What is the difference between the Exports(as % of merchandise exports) in Chile in 2002 and the Exports(as % of merchandise exports) in Singapore in 2004?
Keep it short and to the point. -8.62. What is the difference between the Exports(as % of merchandise exports) of Kuwait in 2002 and the Exports(as % of merchandise exports) of New Caledonia in 2004?
Provide a succinct answer. 91.44. What is the difference between the Exports(as % of merchandise exports) of Kuwait in 2002 and the Exports(as % of merchandise exports) of Singapore in 2004?
Offer a very short reply. 82.67. What is the difference between the Exports(as % of merchandise exports) of New Caledonia in 2002 and the Exports(as % of merchandise exports) of Singapore in 2004?
Provide a succinct answer. -8.62. What is the difference between the Exports(as % of merchandise exports) in Chile in 2003 and the Exports(as % of merchandise exports) in Kuwait in 2004?
Your answer should be compact. -91.84. What is the difference between the Exports(as % of merchandise exports) of Chile in 2003 and the Exports(as % of merchandise exports) of New Caledonia in 2004?
Give a very brief answer. 1.7. What is the difference between the Exports(as % of merchandise exports) in Chile in 2003 and the Exports(as % of merchandise exports) in Singapore in 2004?
Offer a terse response. -7.07. What is the difference between the Exports(as % of merchandise exports) of Kuwait in 2003 and the Exports(as % of merchandise exports) of New Caledonia in 2004?
Provide a short and direct response. 92.39. What is the difference between the Exports(as % of merchandise exports) of Kuwait in 2003 and the Exports(as % of merchandise exports) of Singapore in 2004?
Provide a succinct answer. 83.62. What is the difference between the Exports(as % of merchandise exports) in New Caledonia in 2003 and the Exports(as % of merchandise exports) in Singapore in 2004?
Your answer should be compact. -8.62. What is the average Exports(as % of merchandise exports) of Chile per year?
Keep it short and to the point. 1.54. What is the average Exports(as % of merchandise exports) in Kuwait per year?
Your response must be concise. 89.43. What is the average Exports(as % of merchandise exports) of New Caledonia per year?
Your answer should be compact. 0.92. What is the average Exports(as % of merchandise exports) in Singapore per year?
Your answer should be very brief. 10.97. In the year 1983, what is the difference between the Exports(as % of merchandise exports) in Chile and Exports(as % of merchandise exports) in Kuwait?
Make the answer very short. -77.51. In the year 1983, what is the difference between the Exports(as % of merchandise exports) in Chile and Exports(as % of merchandise exports) in New Caledonia?
Offer a terse response. 1.44. In the year 1983, what is the difference between the Exports(as % of merchandise exports) in Chile and Exports(as % of merchandise exports) in Singapore?
Provide a short and direct response. -26.43. In the year 1983, what is the difference between the Exports(as % of merchandise exports) of Kuwait and Exports(as % of merchandise exports) of New Caledonia?
Make the answer very short. 78.95. In the year 1983, what is the difference between the Exports(as % of merchandise exports) of Kuwait and Exports(as % of merchandise exports) of Singapore?
Your answer should be compact. 51.08. In the year 1983, what is the difference between the Exports(as % of merchandise exports) of New Caledonia and Exports(as % of merchandise exports) of Singapore?
Provide a short and direct response. -27.87. In the year 1999, what is the difference between the Exports(as % of merchandise exports) of Chile and Exports(as % of merchandise exports) of Kuwait?
Your answer should be compact. -78.36. In the year 1999, what is the difference between the Exports(as % of merchandise exports) in Chile and Exports(as % of merchandise exports) in New Caledonia?
Offer a terse response. -0.36. In the year 1999, what is the difference between the Exports(as % of merchandise exports) of Chile and Exports(as % of merchandise exports) of Singapore?
Ensure brevity in your answer.  -7.47. In the year 1999, what is the difference between the Exports(as % of merchandise exports) in Kuwait and Exports(as % of merchandise exports) in New Caledonia?
Give a very brief answer. 78. In the year 1999, what is the difference between the Exports(as % of merchandise exports) in Kuwait and Exports(as % of merchandise exports) in Singapore?
Offer a very short reply. 70.89. In the year 1999, what is the difference between the Exports(as % of merchandise exports) in New Caledonia and Exports(as % of merchandise exports) in Singapore?
Ensure brevity in your answer.  -7.11. In the year 2000, what is the difference between the Exports(as % of merchandise exports) of Chile and Exports(as % of merchandise exports) of Kuwait?
Make the answer very short. -93.17. In the year 2000, what is the difference between the Exports(as % of merchandise exports) in Chile and Exports(as % of merchandise exports) in New Caledonia?
Ensure brevity in your answer.  0.25. In the year 2000, what is the difference between the Exports(as % of merchandise exports) of Chile and Exports(as % of merchandise exports) of Singapore?
Offer a terse response. -6.2. In the year 2000, what is the difference between the Exports(as % of merchandise exports) of Kuwait and Exports(as % of merchandise exports) of New Caledonia?
Give a very brief answer. 93.42. In the year 2000, what is the difference between the Exports(as % of merchandise exports) in Kuwait and Exports(as % of merchandise exports) in Singapore?
Give a very brief answer. 86.97. In the year 2000, what is the difference between the Exports(as % of merchandise exports) of New Caledonia and Exports(as % of merchandise exports) of Singapore?
Your answer should be very brief. -6.45. In the year 2001, what is the difference between the Exports(as % of merchandise exports) in Chile and Exports(as % of merchandise exports) in Kuwait?
Your answer should be compact. -91.75. In the year 2001, what is the difference between the Exports(as % of merchandise exports) in Chile and Exports(as % of merchandise exports) in New Caledonia?
Offer a terse response. 0.36. In the year 2001, what is the difference between the Exports(as % of merchandise exports) in Chile and Exports(as % of merchandise exports) in Singapore?
Your answer should be very brief. -6.08. In the year 2001, what is the difference between the Exports(as % of merchandise exports) of Kuwait and Exports(as % of merchandise exports) of New Caledonia?
Your answer should be compact. 92.11. In the year 2001, what is the difference between the Exports(as % of merchandise exports) in Kuwait and Exports(as % of merchandise exports) in Singapore?
Your answer should be compact. 85.67. In the year 2001, what is the difference between the Exports(as % of merchandise exports) in New Caledonia and Exports(as % of merchandise exports) in Singapore?
Keep it short and to the point. -6.44. In the year 2002, what is the difference between the Exports(as % of merchandise exports) in Chile and Exports(as % of merchandise exports) in Kuwait?
Your answer should be very brief. -91.29. In the year 2002, what is the difference between the Exports(as % of merchandise exports) of Chile and Exports(as % of merchandise exports) of New Caledonia?
Your answer should be very brief. -0.01. In the year 2002, what is the difference between the Exports(as % of merchandise exports) of Chile and Exports(as % of merchandise exports) of Singapore?
Make the answer very short. -6.49. In the year 2002, what is the difference between the Exports(as % of merchandise exports) of Kuwait and Exports(as % of merchandise exports) of New Caledonia?
Keep it short and to the point. 91.28. In the year 2002, what is the difference between the Exports(as % of merchandise exports) in Kuwait and Exports(as % of merchandise exports) in Singapore?
Provide a succinct answer. 84.8. In the year 2002, what is the difference between the Exports(as % of merchandise exports) in New Caledonia and Exports(as % of merchandise exports) in Singapore?
Your answer should be compact. -6.49. In the year 2003, what is the difference between the Exports(as % of merchandise exports) in Chile and Exports(as % of merchandise exports) in Kuwait?
Ensure brevity in your answer.  -90.69. In the year 2003, what is the difference between the Exports(as % of merchandise exports) in Chile and Exports(as % of merchandise exports) in New Caledonia?
Your answer should be very brief. 1.55. In the year 2003, what is the difference between the Exports(as % of merchandise exports) of Chile and Exports(as % of merchandise exports) of Singapore?
Offer a very short reply. -5.67. In the year 2003, what is the difference between the Exports(as % of merchandise exports) in Kuwait and Exports(as % of merchandise exports) in New Caledonia?
Keep it short and to the point. 92.25. In the year 2003, what is the difference between the Exports(as % of merchandise exports) in Kuwait and Exports(as % of merchandise exports) in Singapore?
Offer a very short reply. 85.02. In the year 2003, what is the difference between the Exports(as % of merchandise exports) of New Caledonia and Exports(as % of merchandise exports) of Singapore?
Make the answer very short. -7.23. In the year 2004, what is the difference between the Exports(as % of merchandise exports) in Chile and Exports(as % of merchandise exports) in Kuwait?
Provide a succinct answer. -92.44. In the year 2004, what is the difference between the Exports(as % of merchandise exports) of Chile and Exports(as % of merchandise exports) of New Caledonia?
Provide a short and direct response. 1.1. In the year 2004, what is the difference between the Exports(as % of merchandise exports) in Chile and Exports(as % of merchandise exports) in Singapore?
Ensure brevity in your answer.  -7.67. In the year 2004, what is the difference between the Exports(as % of merchandise exports) in Kuwait and Exports(as % of merchandise exports) in New Caledonia?
Ensure brevity in your answer.  93.54. In the year 2004, what is the difference between the Exports(as % of merchandise exports) in Kuwait and Exports(as % of merchandise exports) in Singapore?
Ensure brevity in your answer.  84.77. In the year 2004, what is the difference between the Exports(as % of merchandise exports) of New Caledonia and Exports(as % of merchandise exports) of Singapore?
Make the answer very short. -8.77. What is the ratio of the Exports(as % of merchandise exports) in Chile in 1983 to that in 1999?
Your answer should be very brief. 3.57. What is the ratio of the Exports(as % of merchandise exports) in Kuwait in 1983 to that in 1999?
Ensure brevity in your answer.  1. What is the ratio of the Exports(as % of merchandise exports) of New Caledonia in 1983 to that in 1999?
Your answer should be compact. 0.18. What is the ratio of the Exports(as % of merchandise exports) in Singapore in 1983 to that in 1999?
Give a very brief answer. 3.54. What is the ratio of the Exports(as % of merchandise exports) of Chile in 1983 to that in 2000?
Your response must be concise. 1.39. What is the ratio of the Exports(as % of merchandise exports) of Kuwait in 1983 to that in 2000?
Offer a very short reply. 0.84. What is the ratio of the Exports(as % of merchandise exports) in New Caledonia in 1983 to that in 2000?
Offer a very short reply. 0.16. What is the ratio of the Exports(as % of merchandise exports) in Singapore in 1983 to that in 2000?
Your response must be concise. 3.82. What is the ratio of the Exports(as % of merchandise exports) of Chile in 1983 to that in 2001?
Give a very brief answer. 1.07. What is the ratio of the Exports(as % of merchandise exports) of Kuwait in 1983 to that in 2001?
Your response must be concise. 0.85. What is the ratio of the Exports(as % of merchandise exports) in New Caledonia in 1983 to that in 2001?
Your response must be concise. 0.13. What is the ratio of the Exports(as % of merchandise exports) in Singapore in 1983 to that in 2001?
Your response must be concise. 3.71. What is the ratio of the Exports(as % of merchandise exports) of Chile in 1983 to that in 2002?
Make the answer very short. 1.31. What is the ratio of the Exports(as % of merchandise exports) in Kuwait in 1983 to that in 2002?
Your answer should be compact. 0.85. What is the ratio of the Exports(as % of merchandise exports) of New Caledonia in 1983 to that in 2002?
Provide a short and direct response. 0.12. What is the ratio of the Exports(as % of merchandise exports) of Singapore in 1983 to that in 2002?
Ensure brevity in your answer.  3.64. What is the ratio of the Exports(as % of merchandise exports) of Chile in 1983 to that in 2003?
Give a very brief answer. 0.57. What is the ratio of the Exports(as % of merchandise exports) of Kuwait in 1983 to that in 2003?
Offer a very short reply. 0.85. What is the ratio of the Exports(as % of merchandise exports) of New Caledonia in 1983 to that in 2003?
Your answer should be compact. 0.12. What is the ratio of the Exports(as % of merchandise exports) of Singapore in 1983 to that in 2003?
Make the answer very short. 3.32. What is the ratio of the Exports(as % of merchandise exports) in Chile in 1983 to that in 2004?
Ensure brevity in your answer.  0.73. What is the ratio of the Exports(as % of merchandise exports) in Kuwait in 1983 to that in 2004?
Provide a short and direct response. 0.84. What is the ratio of the Exports(as % of merchandise exports) in New Caledonia in 1983 to that in 2004?
Offer a terse response. 0.13. What is the ratio of the Exports(as % of merchandise exports) in Singapore in 1983 to that in 2004?
Your answer should be very brief. 2.85. What is the ratio of the Exports(as % of merchandise exports) in Chile in 1999 to that in 2000?
Offer a terse response. 0.39. What is the ratio of the Exports(as % of merchandise exports) of Kuwait in 1999 to that in 2000?
Provide a short and direct response. 0.84. What is the ratio of the Exports(as % of merchandise exports) of New Caledonia in 1999 to that in 2000?
Your answer should be very brief. 0.91. What is the ratio of the Exports(as % of merchandise exports) in Singapore in 1999 to that in 2000?
Your answer should be compact. 1.08. What is the ratio of the Exports(as % of merchandise exports) in Chile in 1999 to that in 2001?
Provide a succinct answer. 0.3. What is the ratio of the Exports(as % of merchandise exports) in Kuwait in 1999 to that in 2001?
Your answer should be very brief. 0.85. What is the ratio of the Exports(as % of merchandise exports) of New Caledonia in 1999 to that in 2001?
Your answer should be compact. 0.72. What is the ratio of the Exports(as % of merchandise exports) of Singapore in 1999 to that in 2001?
Offer a very short reply. 1.05. What is the ratio of the Exports(as % of merchandise exports) of Chile in 1999 to that in 2002?
Give a very brief answer. 0.37. What is the ratio of the Exports(as % of merchandise exports) of Kuwait in 1999 to that in 2002?
Make the answer very short. 0.85. What is the ratio of the Exports(as % of merchandise exports) in New Caledonia in 1999 to that in 2002?
Provide a short and direct response. 0.66. What is the ratio of the Exports(as % of merchandise exports) in Singapore in 1999 to that in 2002?
Keep it short and to the point. 1.03. What is the ratio of the Exports(as % of merchandise exports) in Chile in 1999 to that in 2003?
Give a very brief answer. 0.16. What is the ratio of the Exports(as % of merchandise exports) of Kuwait in 1999 to that in 2003?
Keep it short and to the point. 0.84. What is the ratio of the Exports(as % of merchandise exports) of New Caledonia in 1999 to that in 2003?
Offer a very short reply. 0.66. What is the ratio of the Exports(as % of merchandise exports) in Singapore in 1999 to that in 2003?
Give a very brief answer. 0.94. What is the ratio of the Exports(as % of merchandise exports) of Chile in 1999 to that in 2004?
Offer a very short reply. 0.21. What is the ratio of the Exports(as % of merchandise exports) in Kuwait in 1999 to that in 2004?
Provide a succinct answer. 0.83. What is the ratio of the Exports(as % of merchandise exports) of New Caledonia in 1999 to that in 2004?
Ensure brevity in your answer.  0.75. What is the ratio of the Exports(as % of merchandise exports) of Singapore in 1999 to that in 2004?
Offer a terse response. 0.8. What is the ratio of the Exports(as % of merchandise exports) of Chile in 2000 to that in 2001?
Keep it short and to the point. 0.77. What is the ratio of the Exports(as % of merchandise exports) of Kuwait in 2000 to that in 2001?
Provide a succinct answer. 1.01. What is the ratio of the Exports(as % of merchandise exports) in New Caledonia in 2000 to that in 2001?
Provide a short and direct response. 0.79. What is the ratio of the Exports(as % of merchandise exports) in Singapore in 2000 to that in 2001?
Provide a short and direct response. 0.97. What is the ratio of the Exports(as % of merchandise exports) of Chile in 2000 to that in 2002?
Offer a terse response. 0.94. What is the ratio of the Exports(as % of merchandise exports) of Kuwait in 2000 to that in 2002?
Keep it short and to the point. 1.02. What is the ratio of the Exports(as % of merchandise exports) of New Caledonia in 2000 to that in 2002?
Provide a succinct answer. 0.73. What is the ratio of the Exports(as % of merchandise exports) in Singapore in 2000 to that in 2002?
Your answer should be very brief. 0.95. What is the ratio of the Exports(as % of merchandise exports) in Chile in 2000 to that in 2003?
Your answer should be very brief. 0.41. What is the ratio of the Exports(as % of merchandise exports) in Kuwait in 2000 to that in 2003?
Give a very brief answer. 1.01. What is the ratio of the Exports(as % of merchandise exports) of New Caledonia in 2000 to that in 2003?
Make the answer very short. 0.73. What is the ratio of the Exports(as % of merchandise exports) in Singapore in 2000 to that in 2003?
Offer a terse response. 0.87. What is the ratio of the Exports(as % of merchandise exports) of Chile in 2000 to that in 2004?
Give a very brief answer. 0.53. What is the ratio of the Exports(as % of merchandise exports) of Kuwait in 2000 to that in 2004?
Offer a very short reply. 1. What is the ratio of the Exports(as % of merchandise exports) of New Caledonia in 2000 to that in 2004?
Keep it short and to the point. 0.83. What is the ratio of the Exports(as % of merchandise exports) in Singapore in 2000 to that in 2004?
Keep it short and to the point. 0.75. What is the ratio of the Exports(as % of merchandise exports) of Chile in 2001 to that in 2002?
Offer a terse response. 1.22. What is the ratio of the Exports(as % of merchandise exports) of Kuwait in 2001 to that in 2002?
Your answer should be compact. 1.01. What is the ratio of the Exports(as % of merchandise exports) in New Caledonia in 2001 to that in 2002?
Make the answer very short. 0.92. What is the ratio of the Exports(as % of merchandise exports) of Singapore in 2001 to that in 2002?
Provide a succinct answer. 0.98. What is the ratio of the Exports(as % of merchandise exports) of Chile in 2001 to that in 2003?
Provide a succinct answer. 0.53. What is the ratio of the Exports(as % of merchandise exports) in New Caledonia in 2001 to that in 2003?
Ensure brevity in your answer.  0.93. What is the ratio of the Exports(as % of merchandise exports) of Singapore in 2001 to that in 2003?
Make the answer very short. 0.9. What is the ratio of the Exports(as % of merchandise exports) in Chile in 2001 to that in 2004?
Give a very brief answer. 0.68. What is the ratio of the Exports(as % of merchandise exports) of Kuwait in 2001 to that in 2004?
Make the answer very short. 0.99. What is the ratio of the Exports(as % of merchandise exports) in New Caledonia in 2001 to that in 2004?
Make the answer very short. 1.05. What is the ratio of the Exports(as % of merchandise exports) in Singapore in 2001 to that in 2004?
Keep it short and to the point. 0.77. What is the ratio of the Exports(as % of merchandise exports) in Chile in 2002 to that in 2003?
Your answer should be compact. 0.44. What is the ratio of the Exports(as % of merchandise exports) of Kuwait in 2002 to that in 2003?
Your response must be concise. 0.99. What is the ratio of the Exports(as % of merchandise exports) of New Caledonia in 2002 to that in 2003?
Offer a terse response. 1. What is the ratio of the Exports(as % of merchandise exports) in Singapore in 2002 to that in 2003?
Offer a terse response. 0.91. What is the ratio of the Exports(as % of merchandise exports) in Chile in 2002 to that in 2004?
Give a very brief answer. 0.56. What is the ratio of the Exports(as % of merchandise exports) in Kuwait in 2002 to that in 2004?
Your answer should be very brief. 0.98. What is the ratio of the Exports(as % of merchandise exports) of New Caledonia in 2002 to that in 2004?
Offer a very short reply. 1.14. What is the ratio of the Exports(as % of merchandise exports) in Singapore in 2002 to that in 2004?
Offer a terse response. 0.78. What is the ratio of the Exports(as % of merchandise exports) of Chile in 2003 to that in 2004?
Make the answer very short. 1.28. What is the ratio of the Exports(as % of merchandise exports) of Kuwait in 2003 to that in 2004?
Keep it short and to the point. 0.99. What is the ratio of the Exports(as % of merchandise exports) in New Caledonia in 2003 to that in 2004?
Ensure brevity in your answer.  1.14. What is the ratio of the Exports(as % of merchandise exports) in Singapore in 2003 to that in 2004?
Ensure brevity in your answer.  0.86. What is the difference between the highest and the second highest Exports(as % of merchandise exports) in Chile?
Give a very brief answer. 0.6. What is the difference between the highest and the second highest Exports(as % of merchandise exports) of Kuwait?
Ensure brevity in your answer.  0.29. What is the difference between the highest and the second highest Exports(as % of merchandise exports) in New Caledonia?
Keep it short and to the point. 0.01. What is the difference between the highest and the second highest Exports(as % of merchandise exports) in Singapore?
Your response must be concise. 18.18. What is the difference between the highest and the lowest Exports(as % of merchandise exports) in Chile?
Provide a succinct answer. 2.32. What is the difference between the highest and the lowest Exports(as % of merchandise exports) in Kuwait?
Ensure brevity in your answer.  15.8. What is the difference between the highest and the lowest Exports(as % of merchandise exports) of New Caledonia?
Offer a very short reply. 1.07. What is the difference between the highest and the lowest Exports(as % of merchandise exports) in Singapore?
Provide a short and direct response. 20.67. 